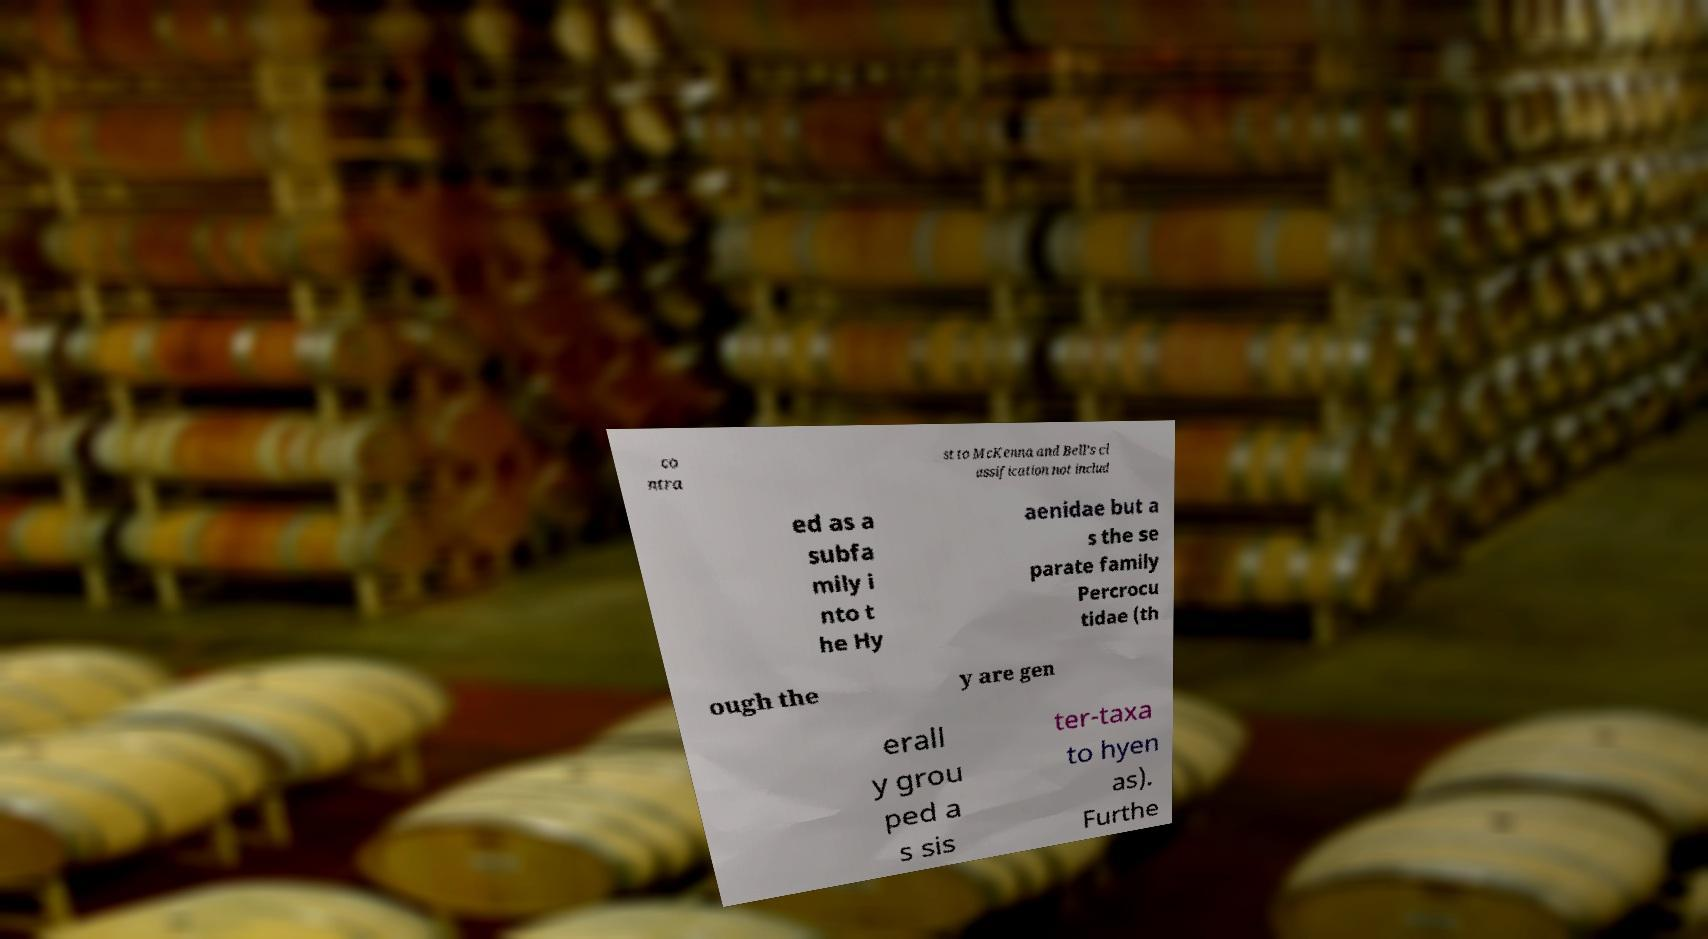Can you read and provide the text displayed in the image?This photo seems to have some interesting text. Can you extract and type it out for me? co ntra st to McKenna and Bell's cl assification not includ ed as a subfa mily i nto t he Hy aenidae but a s the se parate family Percrocu tidae (th ough the y are gen erall y grou ped a s sis ter-taxa to hyen as). Furthe 